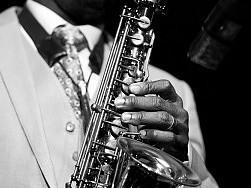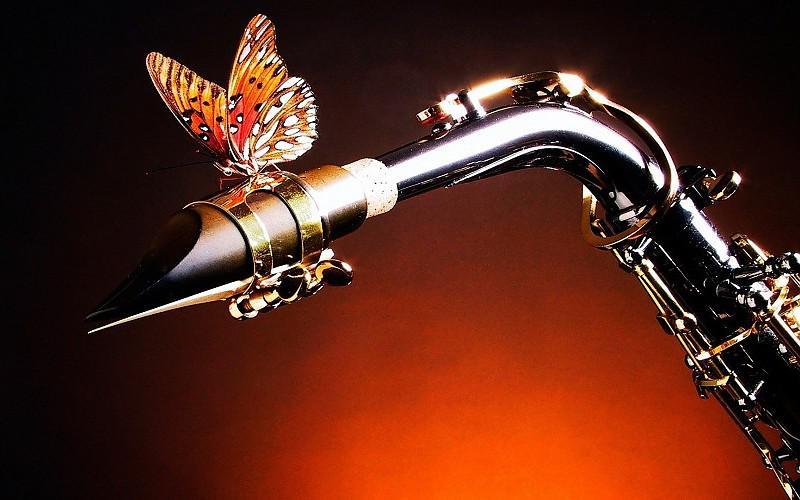The first image is the image on the left, the second image is the image on the right. Analyze the images presented: Is the assertion "One of the images contains a grouping of at least five saxophones, oriented in a variety of positions." valid? Answer yes or no. No. The first image is the image on the left, the second image is the image on the right. For the images shown, is this caption "One image is in color, while the other is a black and white photo of a person holding a saxophone." true? Answer yes or no. Yes. 